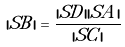<formula> <loc_0><loc_0><loc_500><loc_500>| S B | = { \frac { | S D | | S A | } { | S C | } }</formula> 